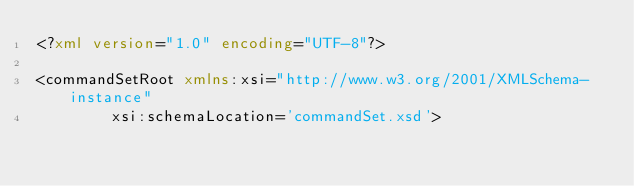Convert code to text. <code><loc_0><loc_0><loc_500><loc_500><_XML_><?xml version="1.0" encoding="UTF-8"?>

<commandSetRoot xmlns:xsi="http://www.w3.org/2001/XMLSchema-instance"
				xsi:schemaLocation='commandSet.xsd'></code> 